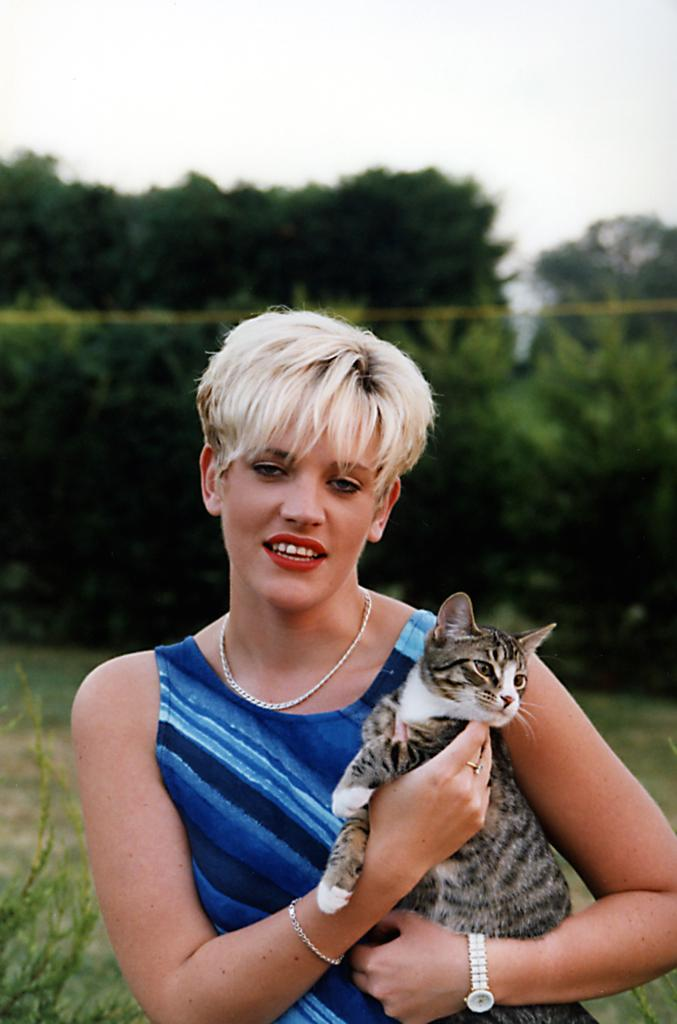Who is the main subject in the image? There is a woman in the image. What is the woman holding in her hands? The woman is holding a cat in her hands. What can be seen in the background of the image? There are trees visible in the background of the image. What is the friction between the cat and the woman's hands in the image? There is no information provided about the friction between the cat and the woman's hands in the image. 